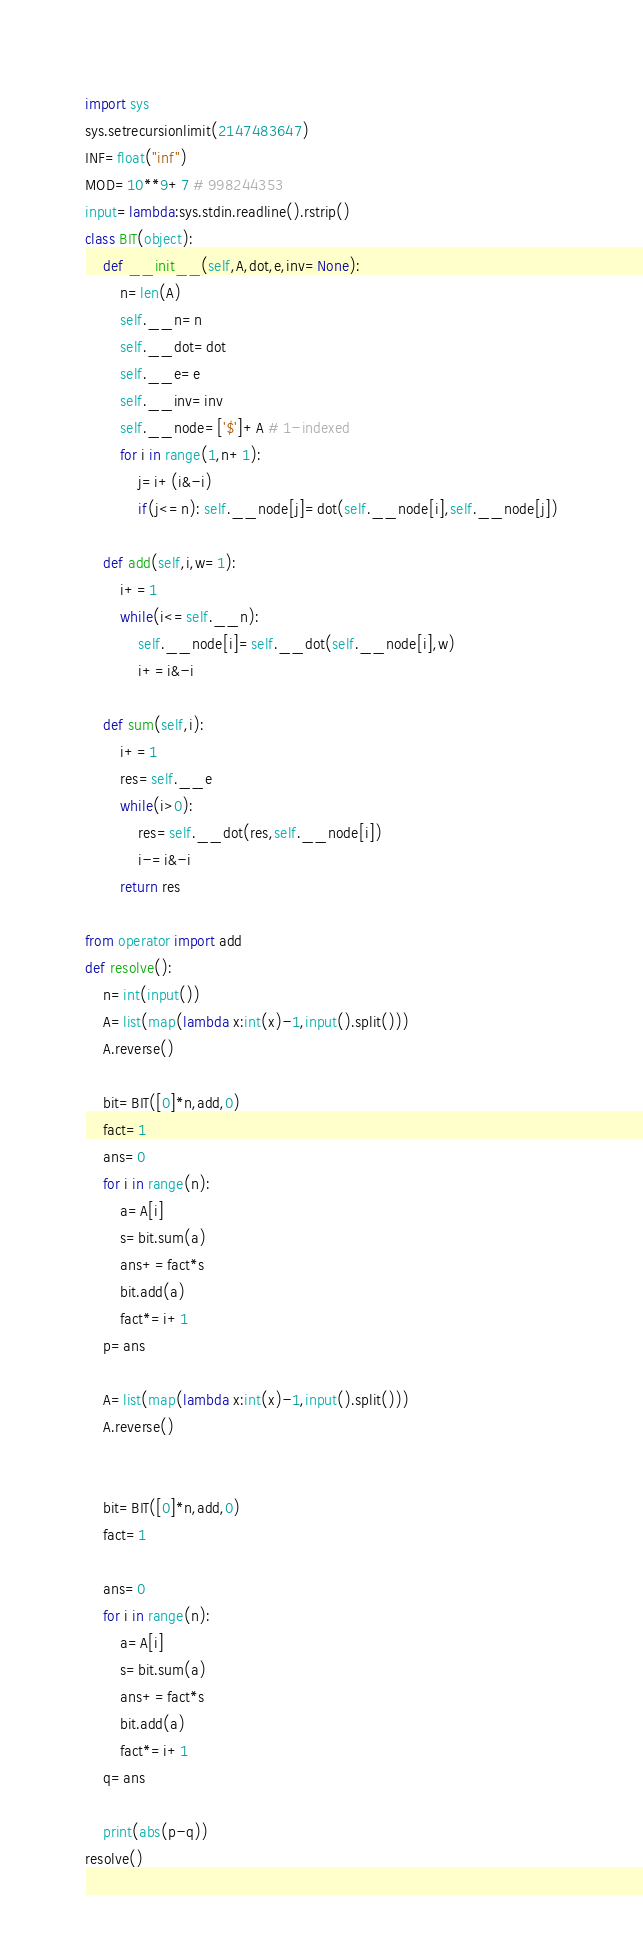Convert code to text. <code><loc_0><loc_0><loc_500><loc_500><_Python_>import sys
sys.setrecursionlimit(2147483647)
INF=float("inf")
MOD=10**9+7 # 998244353
input=lambda:sys.stdin.readline().rstrip()
class BIT(object):
    def __init__(self,A,dot,e,inv=None):
        n=len(A)
        self.__n=n
        self.__dot=dot
        self.__e=e
        self.__inv=inv
        self.__node=['$']+A # 1-indexed
        for i in range(1,n+1):
            j=i+(i&-i)
            if(j<=n): self.__node[j]=dot(self.__node[i],self.__node[j])

    def add(self,i,w=1):
        i+=1
        while(i<=self.__n):
            self.__node[i]=self.__dot(self.__node[i],w)
            i+=i&-i

    def sum(self,i):
        i+=1
        res=self.__e
        while(i>0):
            res=self.__dot(res,self.__node[i])
            i-=i&-i
        return res

from operator import add
def resolve():
    n=int(input())
    A=list(map(lambda x:int(x)-1,input().split()))
    A.reverse()

    bit=BIT([0]*n,add,0)
    fact=1
    ans=0
    for i in range(n):
        a=A[i]
        s=bit.sum(a)
        ans+=fact*s
        bit.add(a)
        fact*=i+1
    p=ans

    A=list(map(lambda x:int(x)-1,input().split()))
    A.reverse()


    bit=BIT([0]*n,add,0)
    fact=1

    ans=0
    for i in range(n):
        a=A[i]
        s=bit.sum(a)
        ans+=fact*s
        bit.add(a)
        fact*=i+1
    q=ans

    print(abs(p-q))
resolve()</code> 